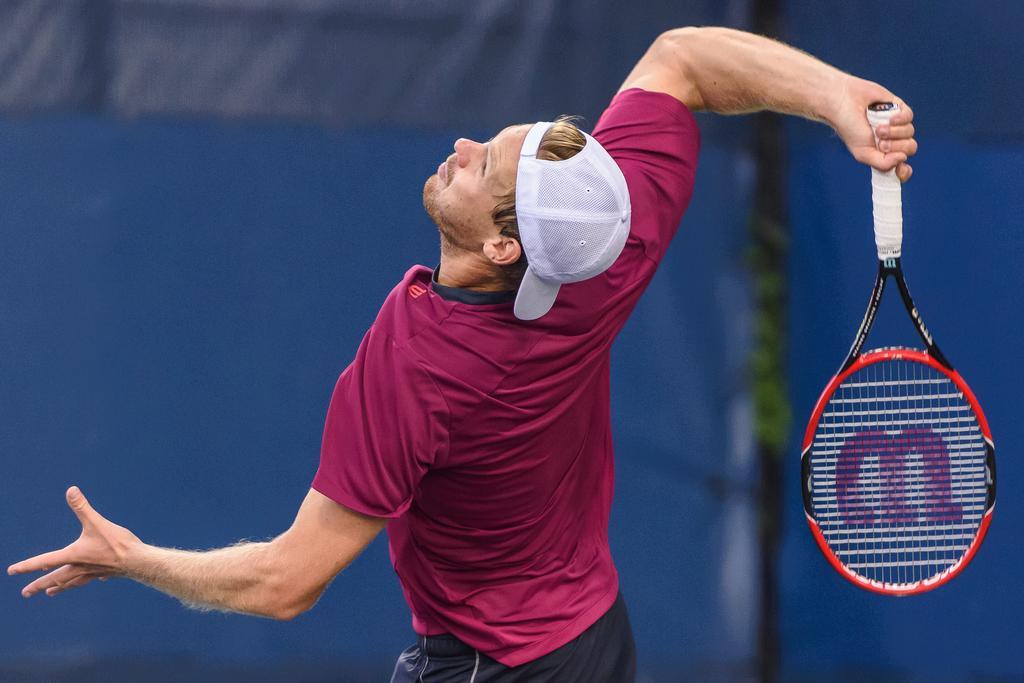How would you summarize this image in a sentence or two? In this picture we can see a man wore a cap and holding a tennis racket with his hand and in the background we can see clothes. 